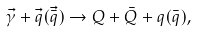Convert formula to latex. <formula><loc_0><loc_0><loc_500><loc_500>\vec { \gamma } + \vec { q } ( \vec { \bar { q } } ) \rightarrow Q + \bar { Q } + q ( \bar { q } ) ,</formula> 